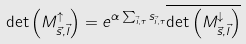<formula> <loc_0><loc_0><loc_500><loc_500>\det \left ( M ^ { \uparrow } _ { \vec { s } , \vec { l } } \right ) = e ^ { \alpha \sum _ { \vec { i } , \tau } s _ { \vec { i } , \tau } } \overline { \det \left ( M ^ { \downarrow } _ { \vec { s } , \vec { l } } \right ) }</formula> 